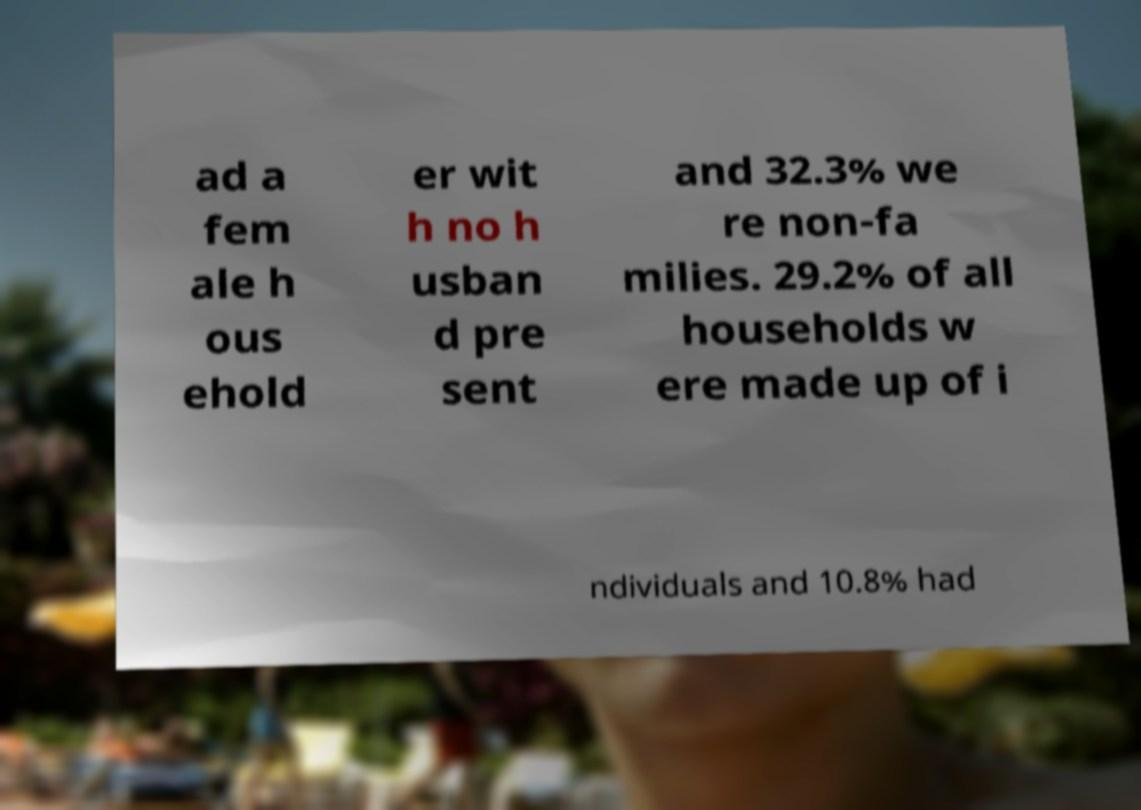I need the written content from this picture converted into text. Can you do that? ad a fem ale h ous ehold er wit h no h usban d pre sent and 32.3% we re non-fa milies. 29.2% of all households w ere made up of i ndividuals and 10.8% had 